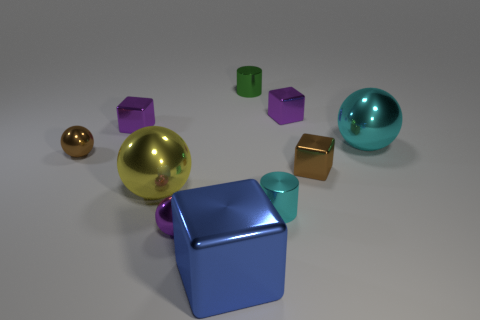There is a purple object on the left side of the purple ball; is its shape the same as the tiny brown metallic object that is right of the blue metallic block?
Keep it short and to the point. Yes. How many tiny purple cubes are in front of the metal cube left of the purple metal thing in front of the brown ball?
Keep it short and to the point. 0. There is a large blue thing that is in front of the brown object that is on the right side of the small block on the left side of the purple metal sphere; what is its material?
Offer a terse response. Metal. Is the brown ball to the left of the yellow metal thing made of the same material as the green thing?
Your answer should be compact. Yes. What number of purple metallic cubes have the same size as the green shiny object?
Make the answer very short. 2. Is the number of purple metal blocks right of the large cube greater than the number of tiny green things that are on the left side of the small brown sphere?
Provide a succinct answer. Yes. Is there a purple metal object that has the same shape as the blue metallic thing?
Ensure brevity in your answer.  Yes. What is the size of the metal sphere to the right of the green cylinder that is behind the tiny cyan cylinder?
Give a very brief answer. Large. The blue metal thing on the left side of the shiny cylinder behind the brown thing to the left of the big block is what shape?
Make the answer very short. Cube. There is a blue thing that is the same material as the purple ball; what size is it?
Give a very brief answer. Large. 